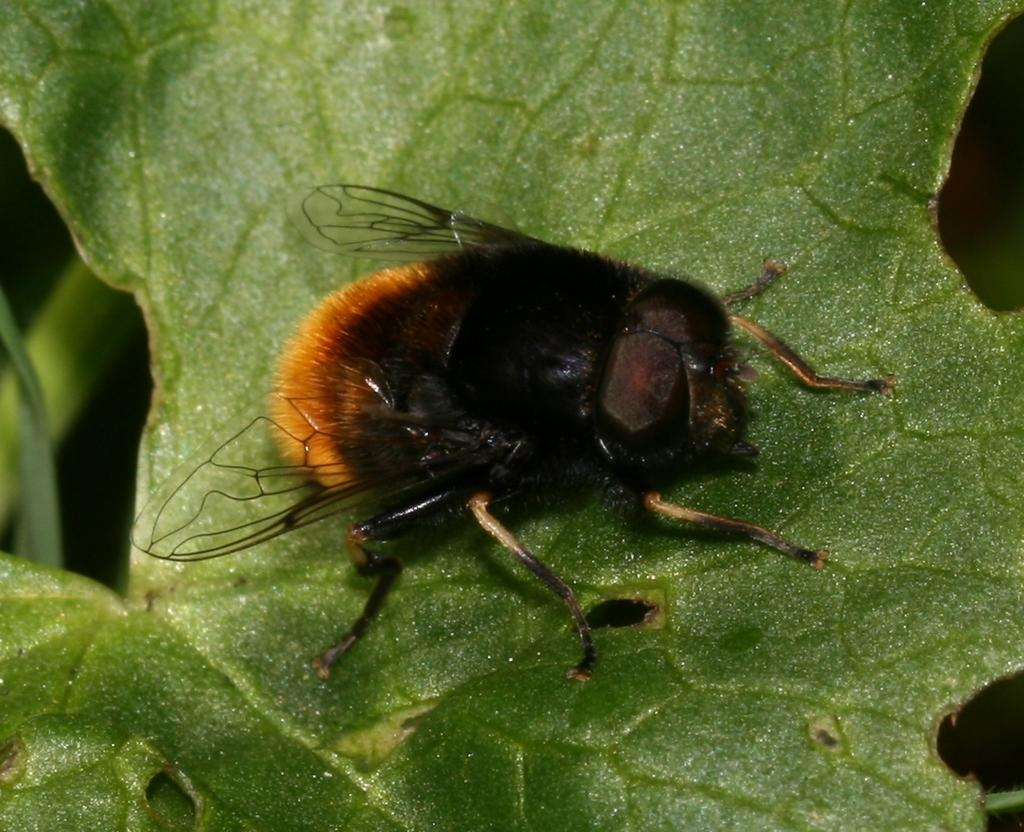What is the main subject of the image? The main subject of the image is a fly on a leaf. What else can be seen on the left side of the image? There is a plant branch on the left side of the image. How would you describe the overall appearance of the image? The background of the image appears dark. What type of kite is being flown by the giants in the image? There are no giants or kites present in the image; it features a fly on a leaf and a plant branch. What is the purpose of the fly in the image? The image does not provide information about the purpose of the fly; it simply shows the fly on a leaf. 